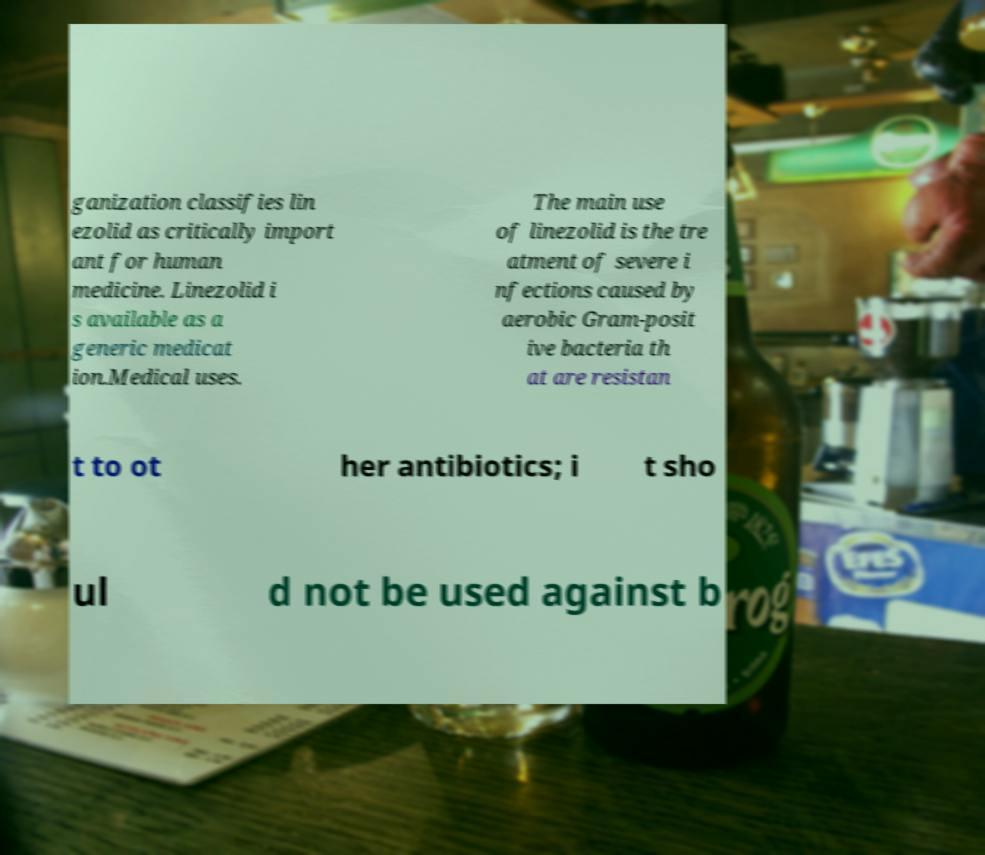For documentation purposes, I need the text within this image transcribed. Could you provide that? ganization classifies lin ezolid as critically import ant for human medicine. Linezolid i s available as a generic medicat ion.Medical uses. The main use of linezolid is the tre atment of severe i nfections caused by aerobic Gram-posit ive bacteria th at are resistan t to ot her antibiotics; i t sho ul d not be used against b 